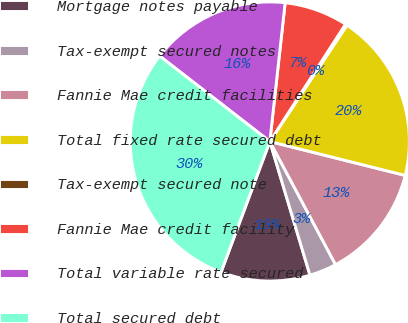<chart> <loc_0><loc_0><loc_500><loc_500><pie_chart><fcel>Mortgage notes payable<fcel>Tax-exempt secured notes<fcel>Fannie Mae credit facilities<fcel>Total fixed rate secured debt<fcel>Tax-exempt secured note<fcel>Fannie Mae credit facility<fcel>Total variable rate secured<fcel>Total secured debt<nl><fcel>10.33%<fcel>3.16%<fcel>13.29%<fcel>19.59%<fcel>0.2%<fcel>7.37%<fcel>16.25%<fcel>29.81%<nl></chart> 